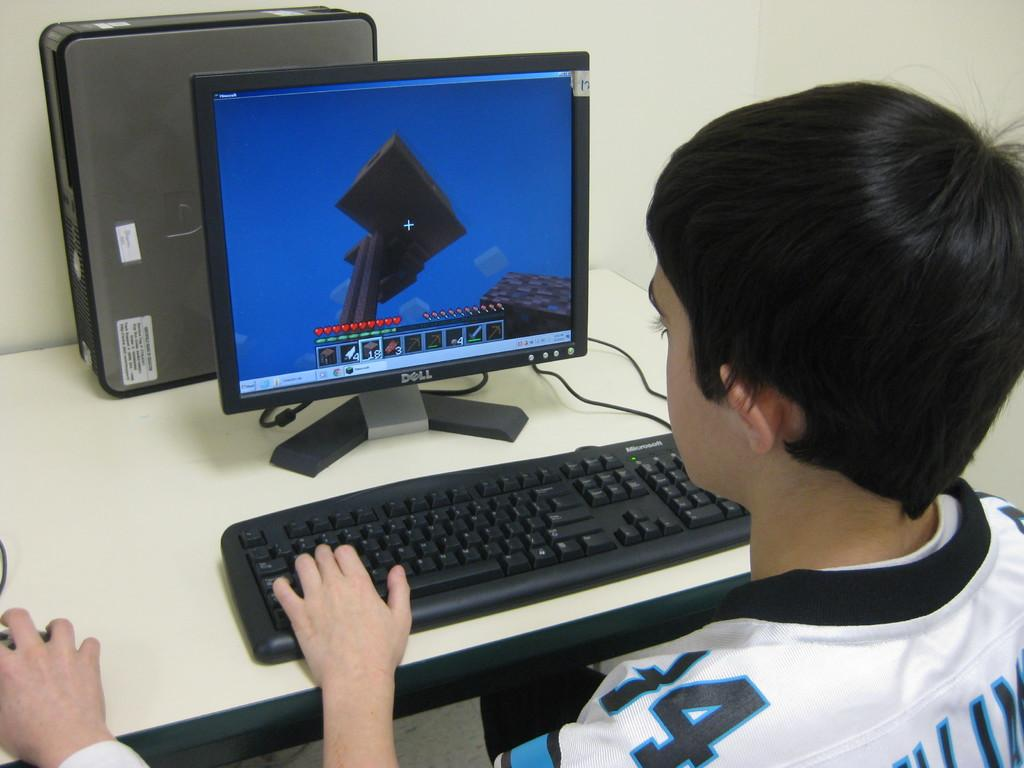<image>
Write a terse but informative summary of the picture. a boy using a DELL computer and keyboard. 